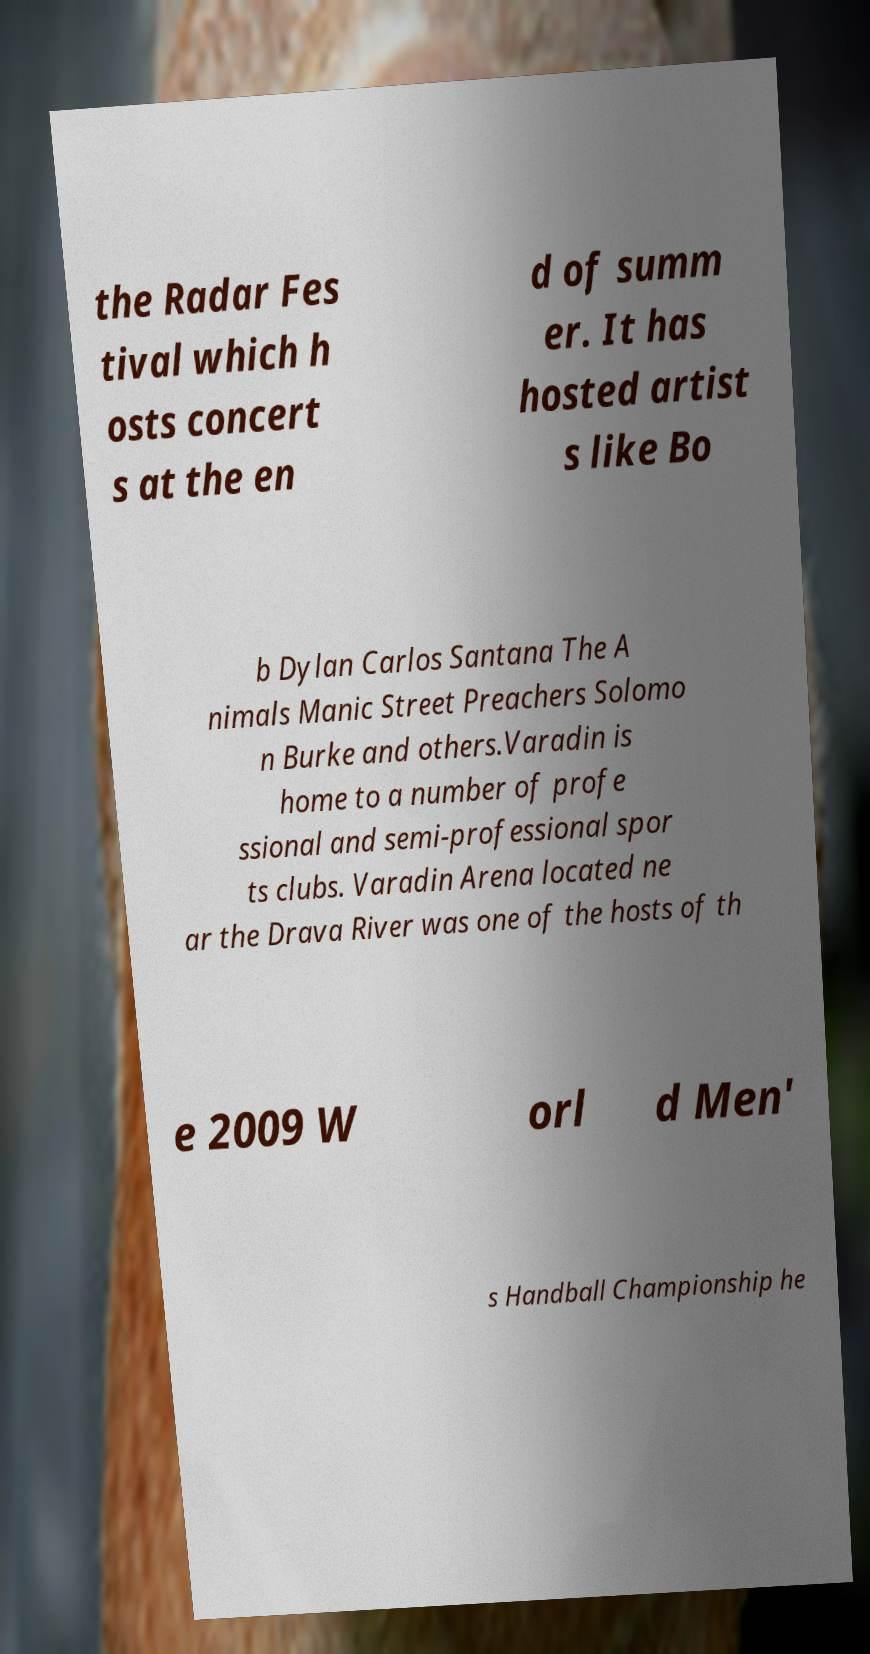Can you accurately transcribe the text from the provided image for me? the Radar Fes tival which h osts concert s at the en d of summ er. It has hosted artist s like Bo b Dylan Carlos Santana The A nimals Manic Street Preachers Solomo n Burke and others.Varadin is home to a number of profe ssional and semi-professional spor ts clubs. Varadin Arena located ne ar the Drava River was one of the hosts of th e 2009 W orl d Men' s Handball Championship he 